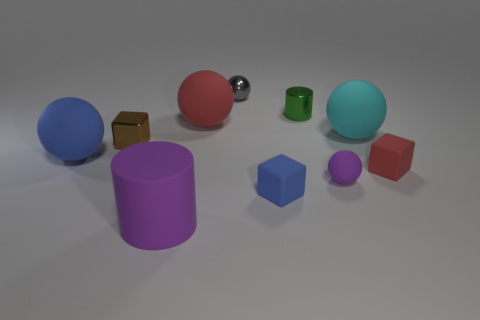The tiny block left of the small rubber block that is to the left of the cube that is on the right side of the small purple rubber sphere is what color?
Provide a succinct answer. Brown. What shape is the small object that is both to the left of the tiny red rubber thing and to the right of the metal cylinder?
Offer a terse response. Sphere. What is the color of the big ball on the right side of the metal thing that is to the right of the tiny blue block?
Ensure brevity in your answer.  Cyan. There is a red thing left of the large sphere to the right of the small shiny thing that is to the right of the tiny gray shiny thing; what is its shape?
Offer a terse response. Sphere. How big is the rubber object that is both left of the big red object and behind the large purple cylinder?
Your response must be concise. Large. What number of spheres have the same color as the big rubber cylinder?
Offer a terse response. 1. There is a tiny ball that is the same color as the matte cylinder; what is it made of?
Keep it short and to the point. Rubber. What is the red cube made of?
Provide a succinct answer. Rubber. Is the tiny ball right of the small gray ball made of the same material as the tiny brown block?
Provide a short and direct response. No. The big matte object to the left of the purple matte cylinder has what shape?
Make the answer very short. Sphere. 